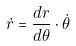Convert formula to latex. <formula><loc_0><loc_0><loc_500><loc_500>\dot { r } = \frac { d r } { d \theta } \cdot \dot { \theta }</formula> 